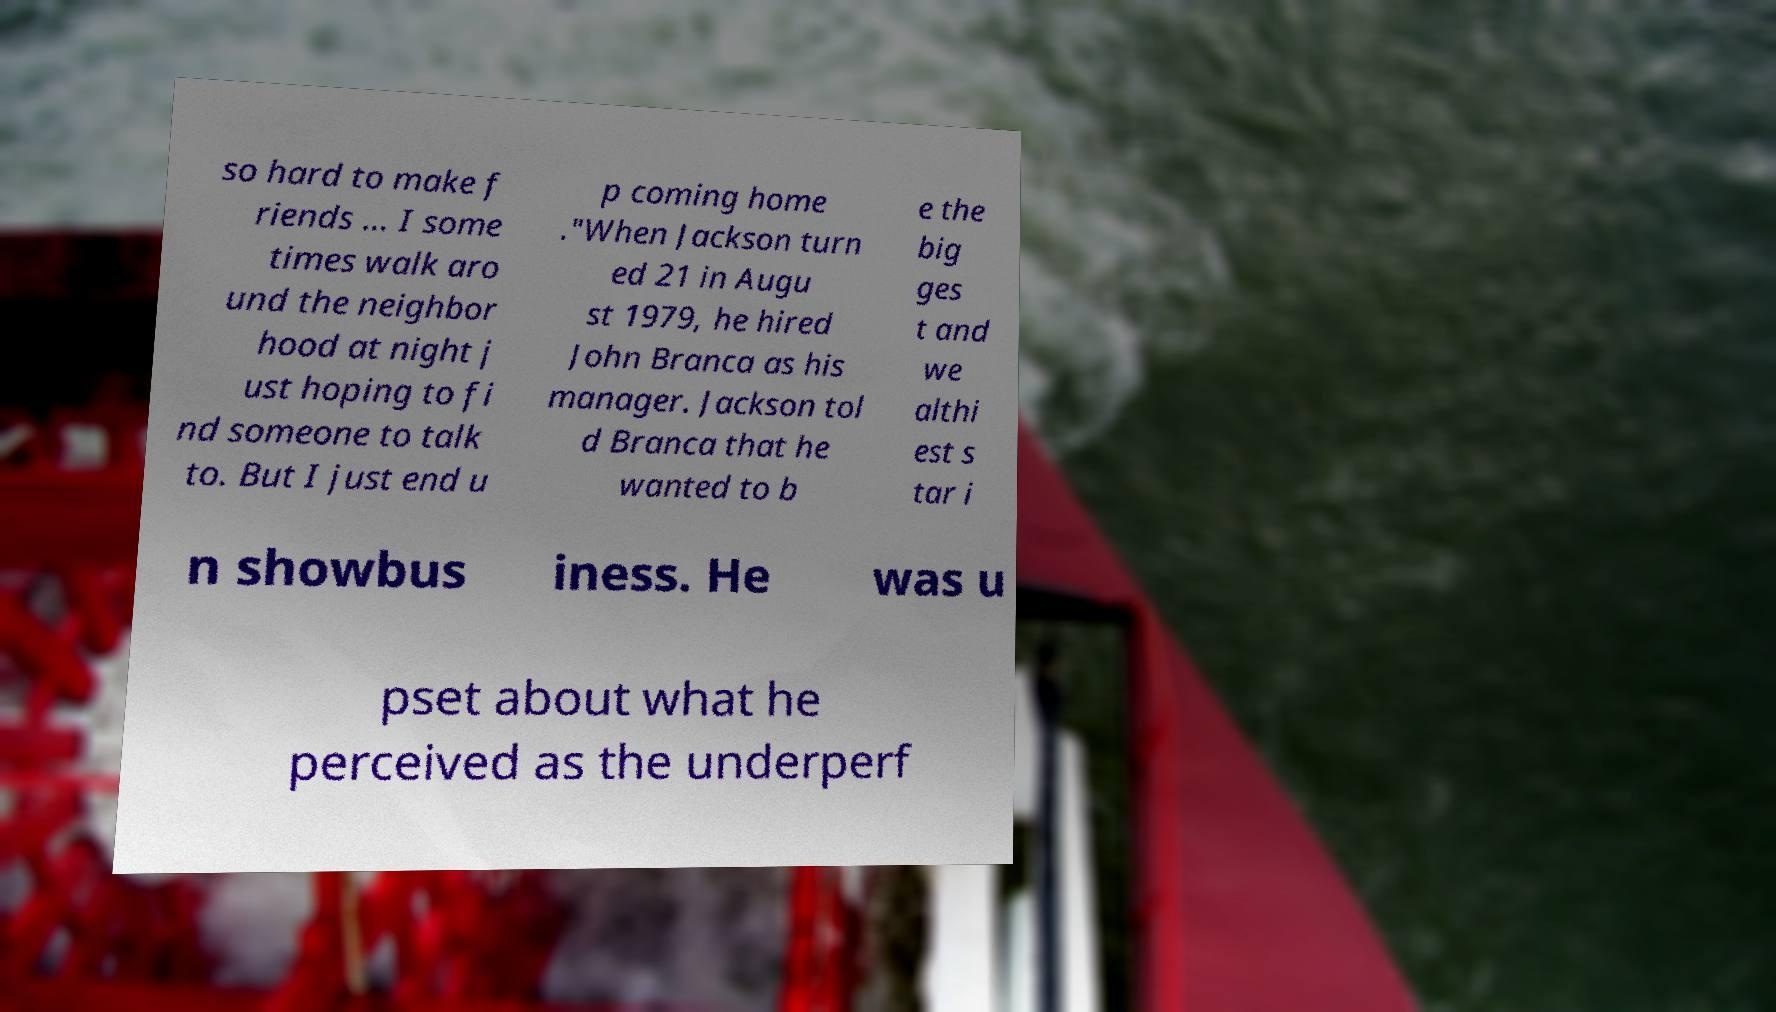Please read and relay the text visible in this image. What does it say? so hard to make f riends ... I some times walk aro und the neighbor hood at night j ust hoping to fi nd someone to talk to. But I just end u p coming home ."When Jackson turn ed 21 in Augu st 1979, he hired John Branca as his manager. Jackson tol d Branca that he wanted to b e the big ges t and we althi est s tar i n showbus iness. He was u pset about what he perceived as the underperf 